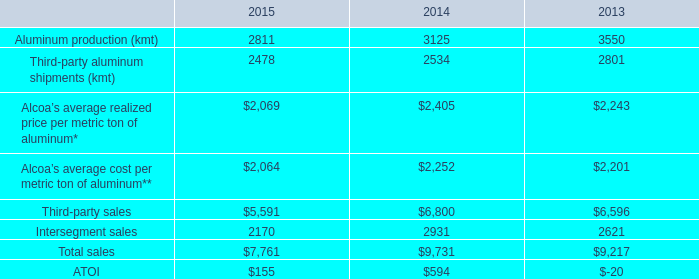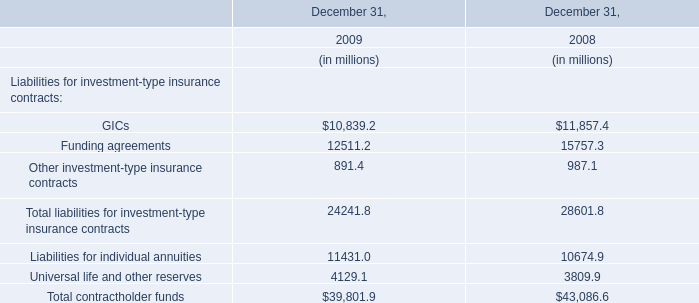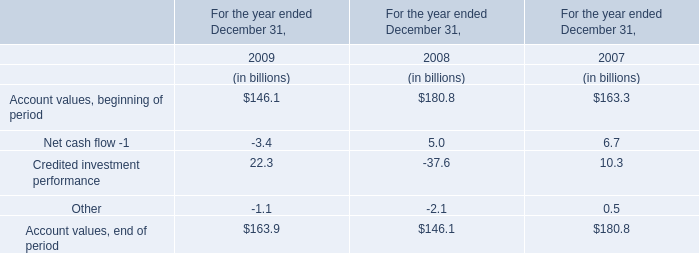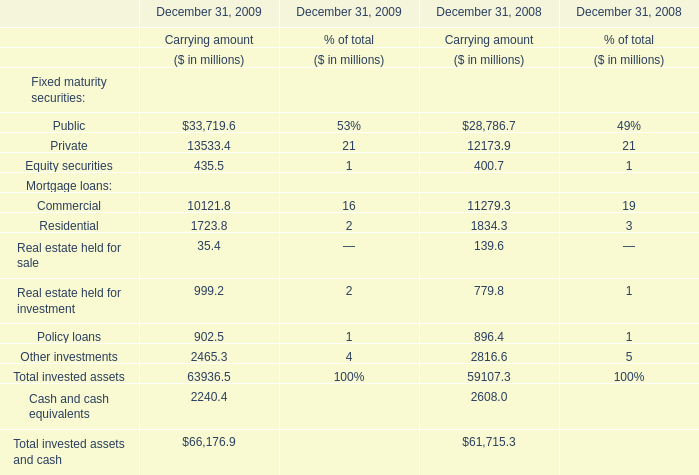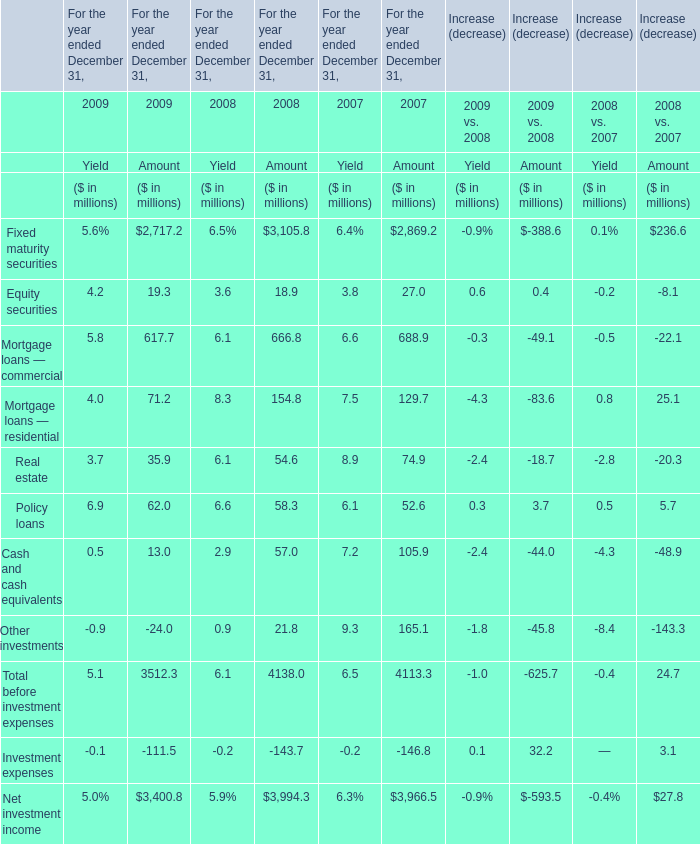In the year for yield with largest amount of Mortgage loans — residential, what's the sum of Real estate and Policy loans ? (in million) 
Computations: (6.1 + 6.6)
Answer: 12.7. 